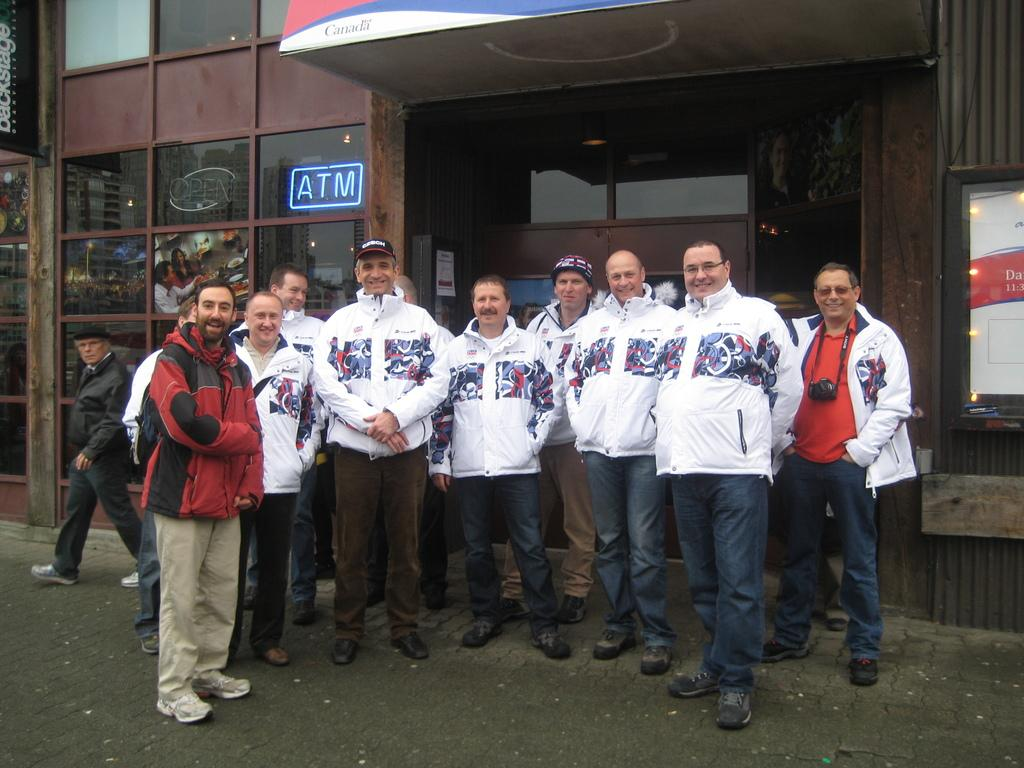<image>
Offer a succinct explanation of the picture presented. A bunch of men stand around in front of a sign saying ATM. 